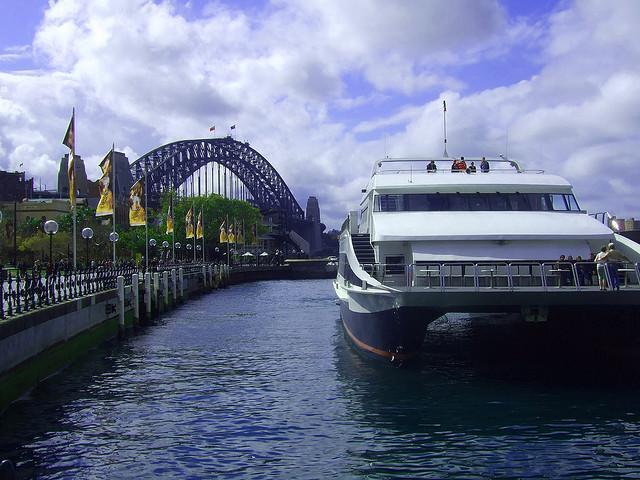How many slices of pizza are shown?
Give a very brief answer. 0. 